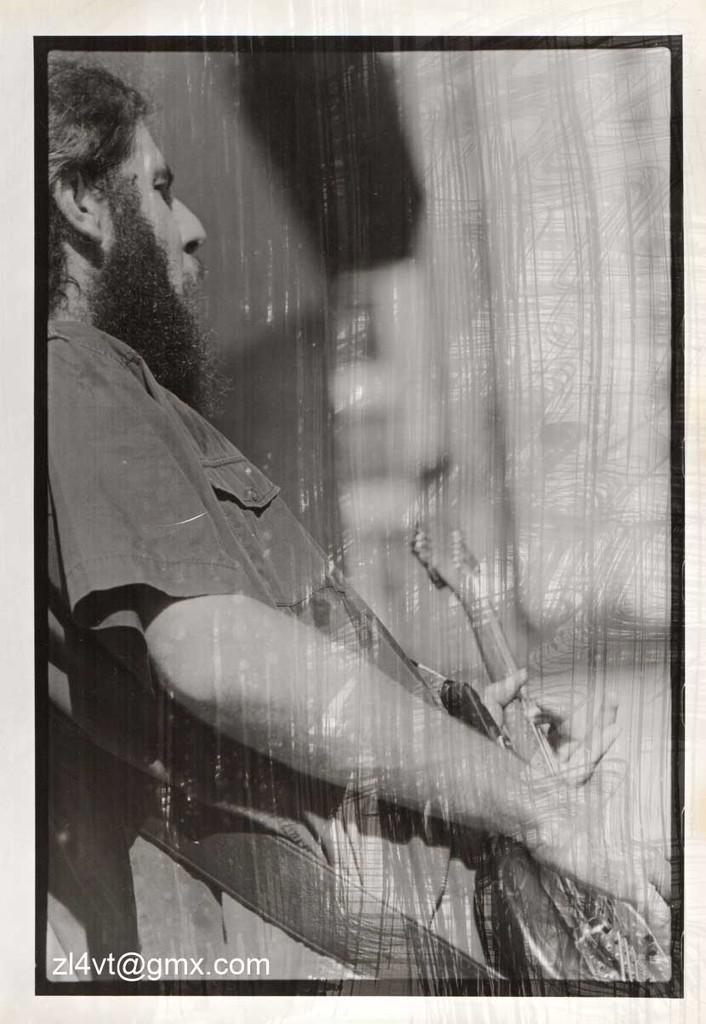What is the main subject of the image? The main subject of the image is a photo. Can you describe the person in the image? There is a man standing in the image. What is the man holding in the image? The man is holding an object. What type of humor can be seen in the man's facial expression in the image? There is no indication of the man's facial expression in the image, so it cannot be determined if there is any humor present. 